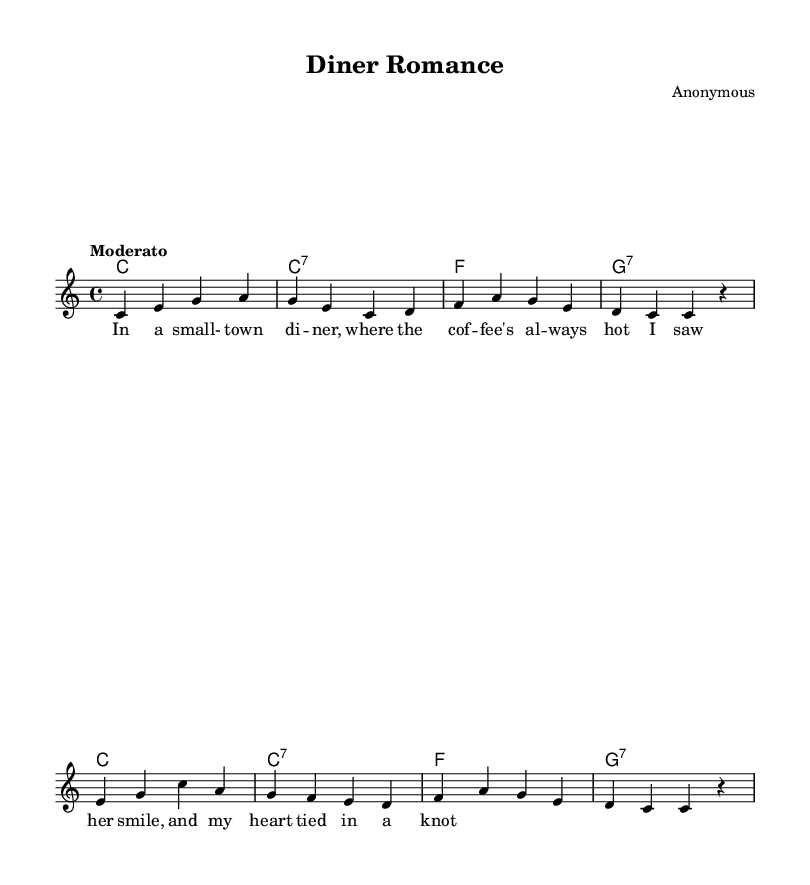What is the key signature of this music? The key signature is C major, which has no sharps or flats.
Answer: C major What is the time signature of this piece? The time signature is indicated by the numbers in the music, which shows that there are four beats in each measure.
Answer: 4/4 What is the tempo indication of the piece? The tempo is marked as "Moderato," which suggests a moderate speed for the piece, typically around 108-120 beats per minute.
Answer: Moderato How many measures are in the melody part? By counting the individual segments separated by the vertical lines (bars), there are eight measures in total for the melody.
Answer: Eight What is the first chord played in the harmony section? The first chord in the harmony section is identified by the notation at the beginning of the line and is a C major chord.
Answer: C How many lines of lyrics are associated with the melody? The lyrics are presented as phrases that align with the melody, and there is only one complete line of lyrics shown in this score.
Answer: One In the lyrics, what is the emotional context suggested by the first two lines? The lyrics convey a sense of nostalgia and warmth, hinting at a romantic moment experienced in a diner, emphasizing the comforting atmosphere of love.
Answer: Nostalgia 